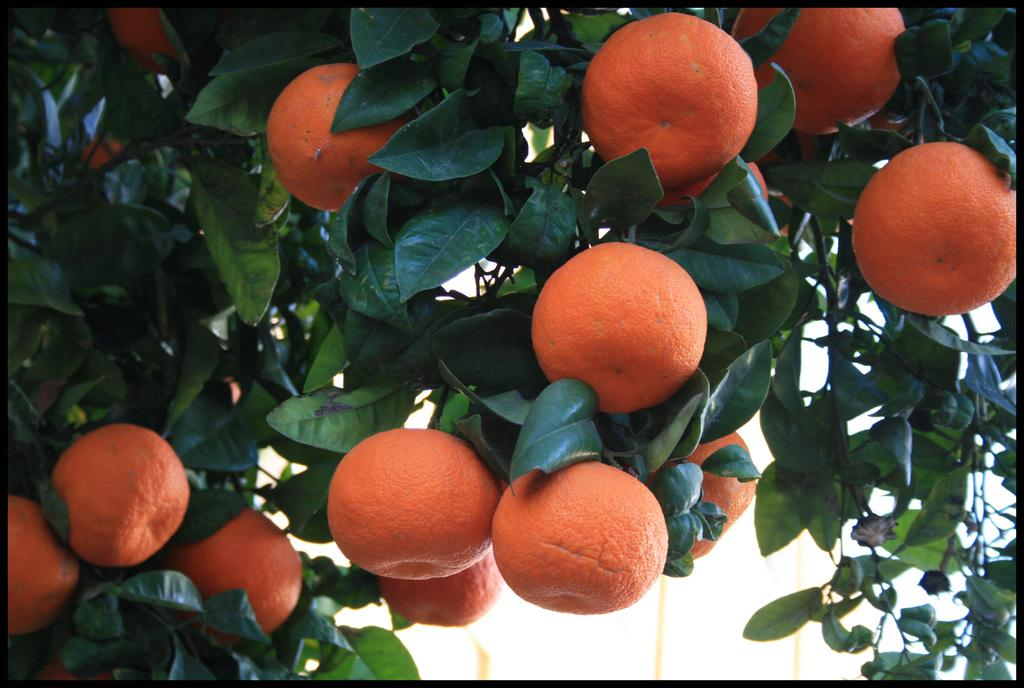What type of plant can be seen in the image? There is a tree in the image. What is unique about the tree's fruits? The tree has orange fruits. What color are the fruits on the tree? The fruits are orange in color. What can be seen in the background of the image? There is a white wall in the background of the image. What type of seat is visible in the image? There is no seat present in the image; it only features a tree with orange fruits and a white wall in the background. 